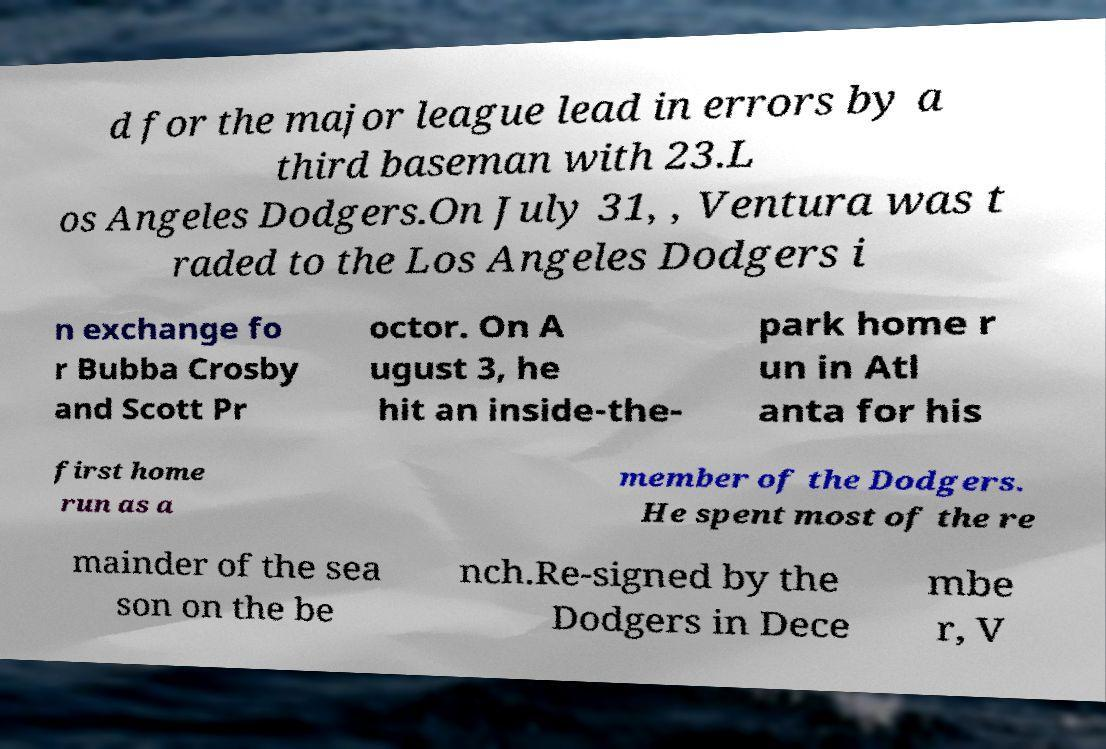Can you accurately transcribe the text from the provided image for me? d for the major league lead in errors by a third baseman with 23.L os Angeles Dodgers.On July 31, , Ventura was t raded to the Los Angeles Dodgers i n exchange fo r Bubba Crosby and Scott Pr octor. On A ugust 3, he hit an inside-the- park home r un in Atl anta for his first home run as a member of the Dodgers. He spent most of the re mainder of the sea son on the be nch.Re-signed by the Dodgers in Dece mbe r, V 